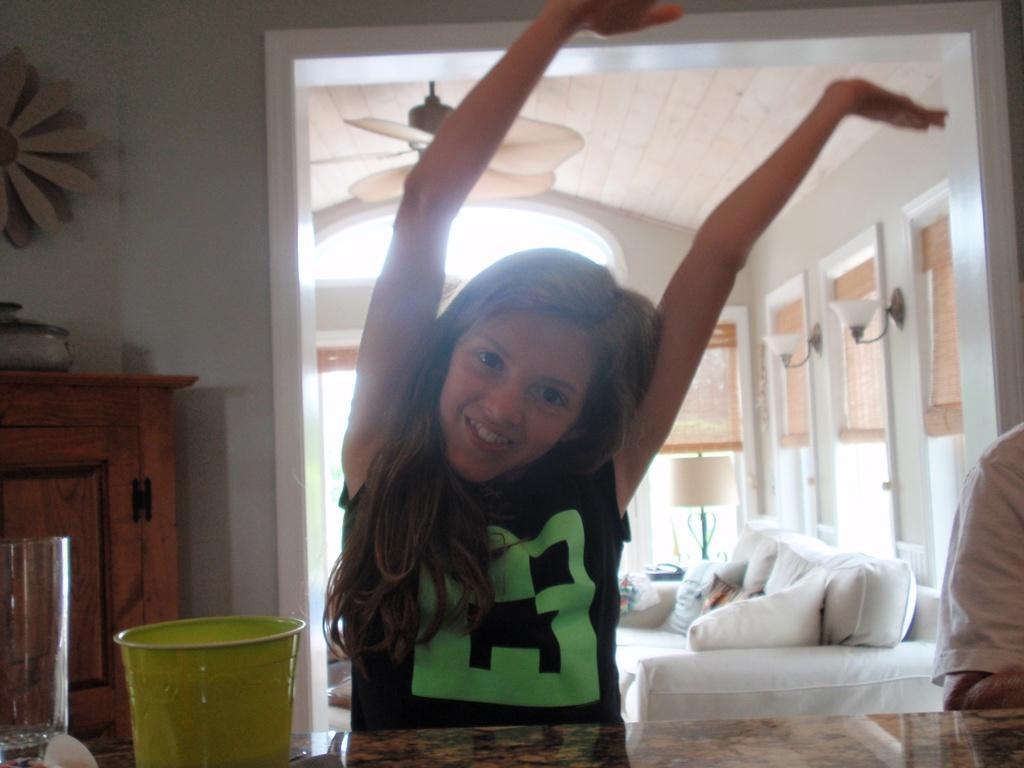In one or two sentences, can you explain what this image depicts? In this picture, there is a girl sitting beside the table. On the table, there is a bowl and a glass. Towards the right corner, there is a person. Behind the girl, there is an entrance for another room. Towards the right, there is a sofa with pillows. Behind the sofa, there is a lamp. On the top, there is a fan. Towards the left, there is a desk. On the desk, there is a vessel. 